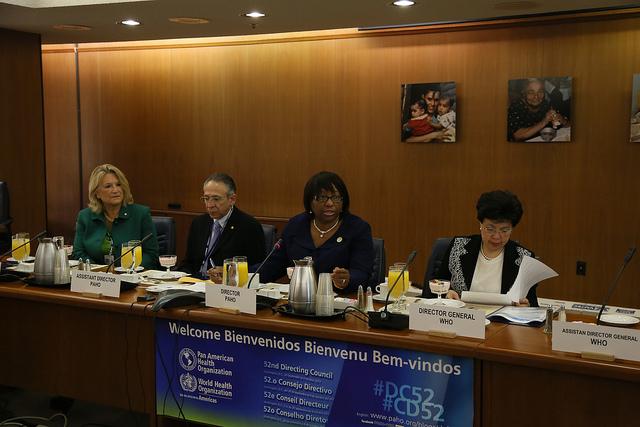How many people are in the image?
Keep it brief. 4. How many people are shown?
Concise answer only. 4. Where are the people located?
Give a very brief answer. Conference table. What room is pictured?
Answer briefly. Meeting room. Are they in a kitchen?
Concise answer only. No. Do the people have microphones?
Quick response, please. Yes. Are the people seated?
Be succinct. Yes. Is this a kitchen?
Quick response, please. No. 